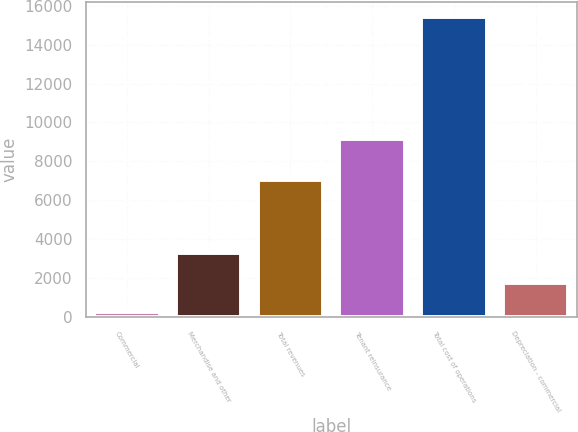Convert chart. <chart><loc_0><loc_0><loc_500><loc_500><bar_chart><fcel>Commercial<fcel>Merchandise and other<fcel>Total revenues<fcel>Tenant reinsurance<fcel>Total cost of operations<fcel>Depreciation - commercial<nl><fcel>225<fcel>3266.6<fcel>7060<fcel>9145<fcel>15433<fcel>1745.8<nl></chart> 